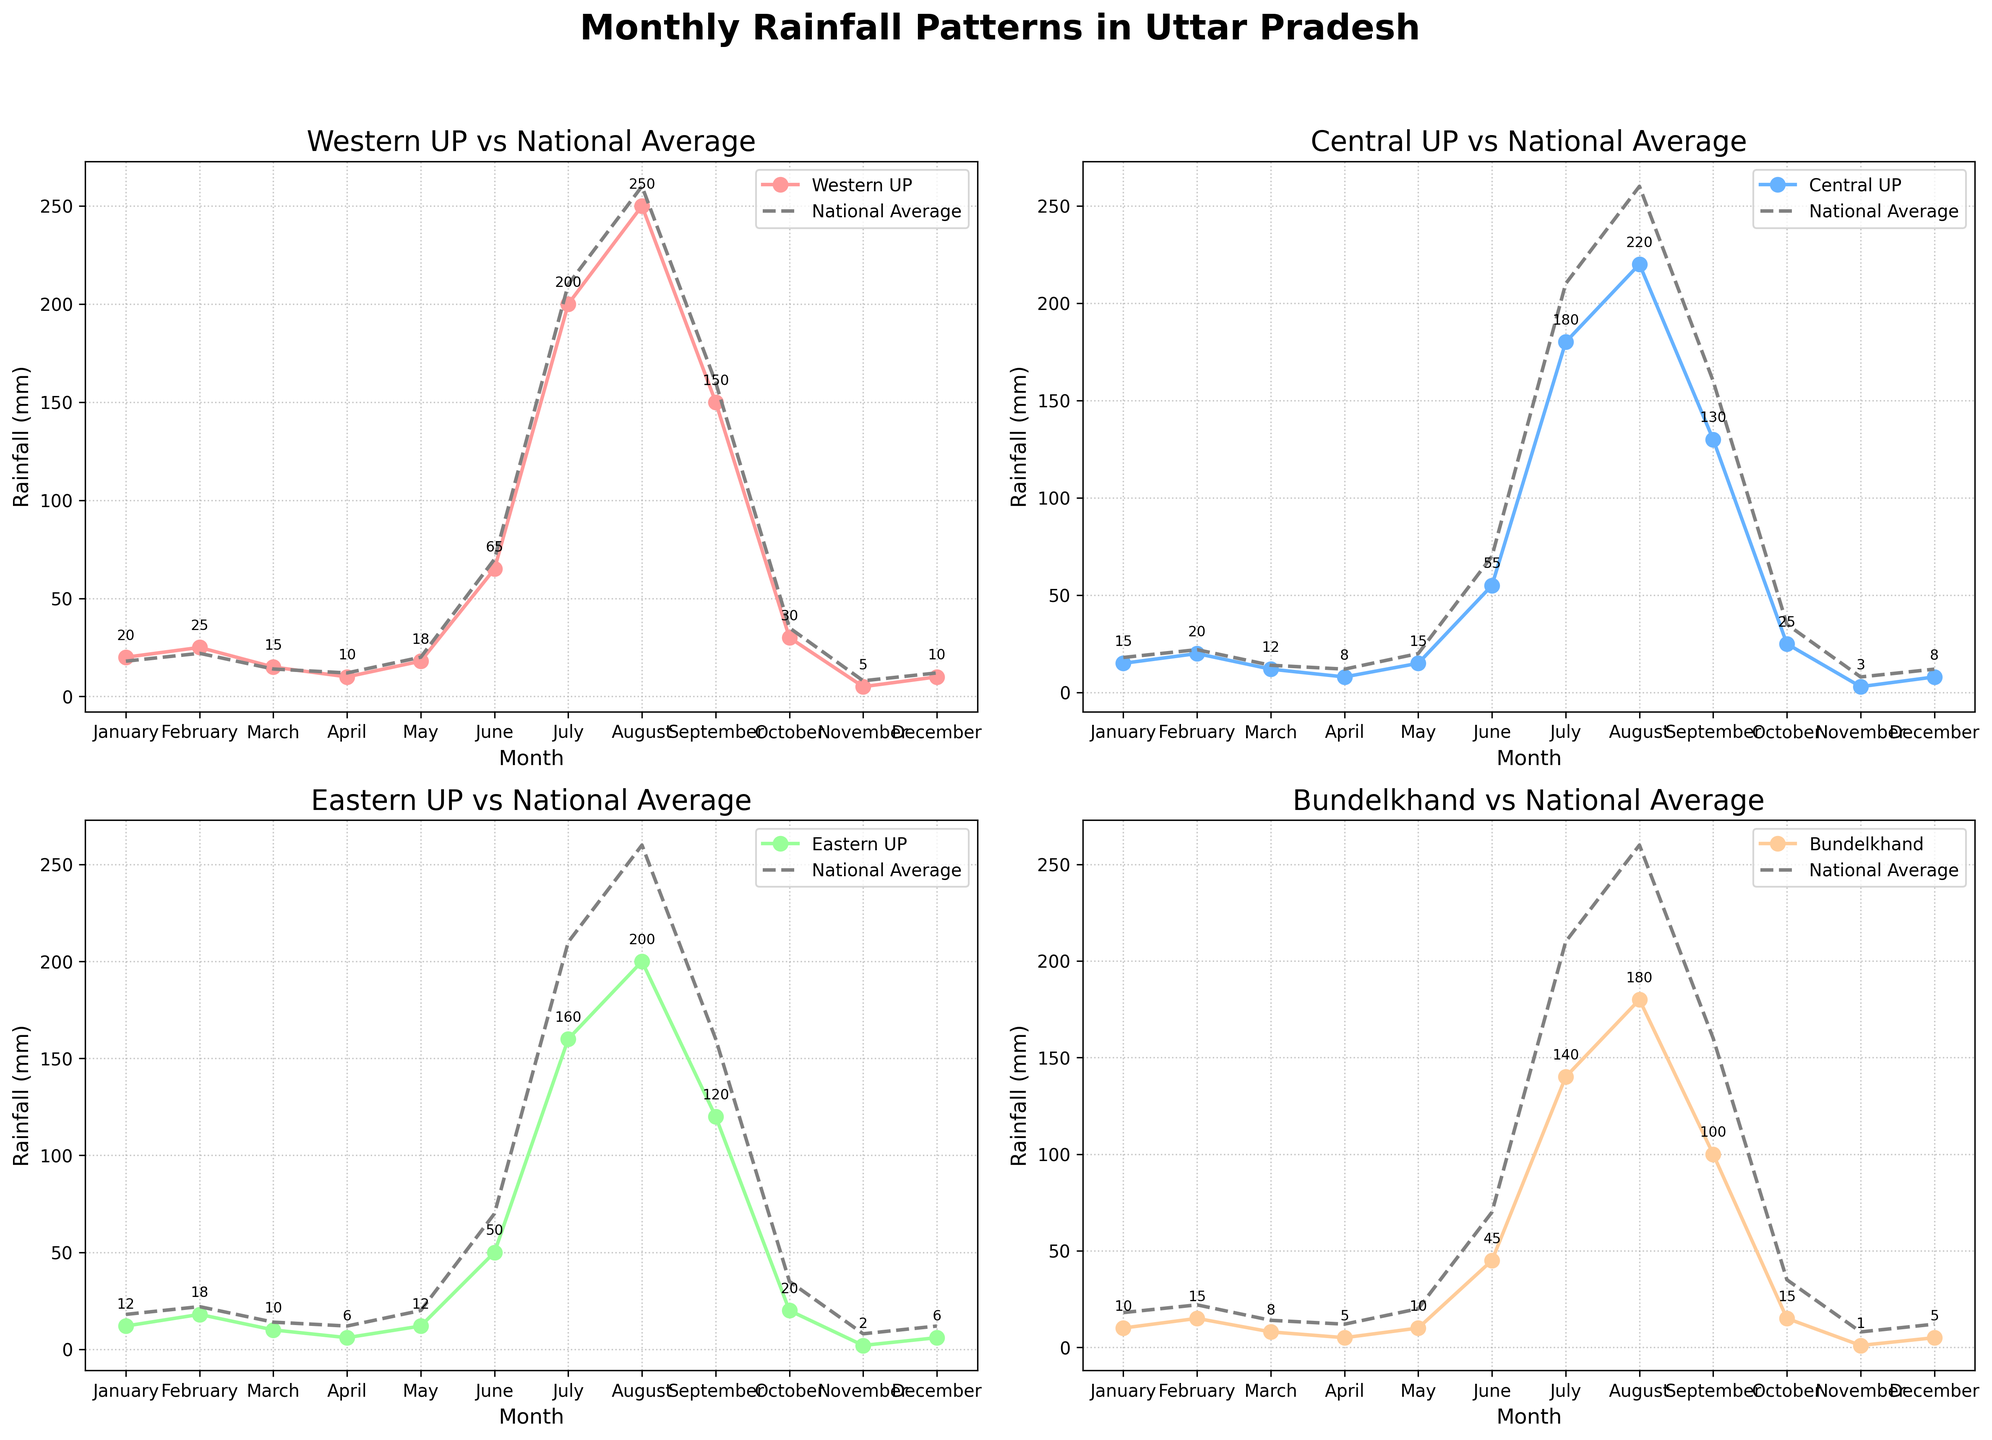How many months have rainfall above 200 mm in Western UP? To find the months with rainfall above 200 mm in Western UP, we observe the plot for Western UP. The plot shows that July and August have rainfall values above 200 mm.
Answer: 2 What is the highest rainfall month for Bundelkhand? To determine the highest rainfall month in Bundelkhand, we look at the peak point in the Bundelkhand plot. August shows the highest rainfall with a value of 180 mm.
Answer: August Which region has the closest rainfall pattern to the National Average in August? For this, we compare the rainfall values for all regions with the National Average for August. The values are Western UP (250 mm), Central UP (220 mm), Eastern UP (200 mm), Bundelkhand (180 mm), and National Average (260 mm). Central UP has the closest value to the National Average (220 mm vs 260 mm).
Answer: Central UP During which months does Eastern UP have less rainfall than the National Average? To find the months where Eastern UP has less rainfall than the National Average, we compare both series on the plot for Eastern UP. These months are January, February, March, April, May, June, July, August, September, October, November, and December because Eastern UP has rainfall values consistently less than the National Average in all months.
Answer: All months In which months is the difference in rainfall between Western UP and Bundelkhand more than 50 mm? We calculate the difference in monthly rainfall between Western UP and Bundelkhand, noting those where the difference exceeds 50 mm. These months are January (10 mm), February (10 mm), March (7 mm), April (5 mm), May (8 mm), June (20 mm), July (60 mm), August (70 mm), September (50 mm), October (15 mm), November (4 mm), and December (5 mm). Thus, July and August have more than a 50 mm difference.
Answer: July, August Which region has the least rainfall in November? Observing the plots for all regions, we note the lowest point for November. Bundelkhand has the least rainfall with a value of 1 mm.
Answer: Bundelkhand What is the average rainfall for Central UP across all months? To find the average, we sum up the values for Central UP across all months and divide by the number of months. The values are 15, 20, 12, 8, 15, 55, 180, 220, 130, 25, 3, 8. Sum = 691 mm. Number of months = 12. Average = 691/12 ≈ 57.58 mm.
Answer: 57.58 mm How does Eastern UP's July rainfall compare to the National Average for the same month? Checking the value for Eastern UP in July (160 mm) and comparing it to the National Average in July (210 mm), Eastern UP's rainfall in July is 50 mm less than the National Average for that month.
Answer: 50 mm less What is the total annual rainfall in Bundelkhand? Adding up the monthly rainfall values for Bundelkhand: 10 + 15 + 8 + 5 + 10 + 45 + 140 + 180 + 100 + 15 + 1 + 5 = 534 mm. So, the total annual rainfall is 534 mm.
Answer: 534 mm Which month has the smallest range of rainfall between the four regions? The range is calculated as the difference between the highest and lowest rainfall values among the four regions for each month. Reviewing all months, November shows the smallest range (5 mm in Western UP, 3 mm in Central UP, 2 mm in Eastern UP, 1 mm in Bundelkhand). Range = 5 - 1 = 4 mm.
Answer: November 